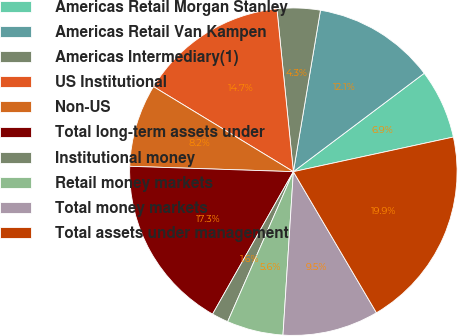Convert chart to OTSL. <chart><loc_0><loc_0><loc_500><loc_500><pie_chart><fcel>Americas Retail Morgan Stanley<fcel>Americas Retail Van Kampen<fcel>Americas Intermediary(1)<fcel>US Institutional<fcel>Non-US<fcel>Total long-term assets under<fcel>Institutional money<fcel>Retail money markets<fcel>Total money markets<fcel>Total assets under management<nl><fcel>6.87%<fcel>12.09%<fcel>4.25%<fcel>14.7%<fcel>8.17%<fcel>17.31%<fcel>1.64%<fcel>5.56%<fcel>9.48%<fcel>19.92%<nl></chart> 